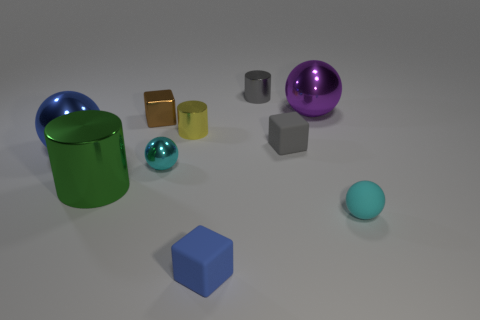The blue thing that is the same shape as the small gray rubber thing is what size?
Ensure brevity in your answer.  Small. There is a ball that is in front of the small brown object and on the right side of the tiny yellow object; what is its size?
Your answer should be very brief. Small. Is the color of the small rubber ball the same as the small metallic cylinder that is on the right side of the blue cube?
Make the answer very short. No. What number of yellow things are either tiny matte objects or small cylinders?
Keep it short and to the point. 1. What is the shape of the gray rubber thing?
Provide a short and direct response. Cube. What number of other things are the same shape as the big blue metallic object?
Ensure brevity in your answer.  3. The cylinder behind the big purple metal thing is what color?
Keep it short and to the point. Gray. Are the small yellow cylinder and the small gray cylinder made of the same material?
Offer a terse response. Yes. What number of things are large green metallic cylinders or spheres in front of the large purple metal object?
Your answer should be very brief. 4. What size is the rubber sphere that is the same color as the small metal sphere?
Keep it short and to the point. Small. 